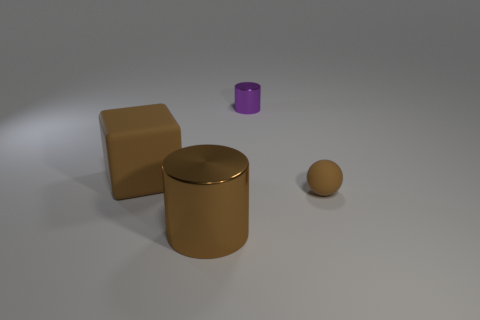Does the small purple metal object have the same shape as the brown shiny thing?
Keep it short and to the point. Yes. There is a small object that is to the right of the small purple shiny thing; are there any cubes that are behind it?
Give a very brief answer. Yes. Is there a brown metal object?
Your answer should be very brief. Yes. There is a object that is to the left of the metallic cylinder in front of the small purple cylinder; what is its color?
Ensure brevity in your answer.  Brown. What number of brown metallic things are the same size as the brown rubber ball?
Make the answer very short. 0. What is the size of the thing that is the same material as the sphere?
Provide a succinct answer. Large. How many large brown things are the same shape as the tiny purple thing?
Offer a very short reply. 1. What number of small brown balls are there?
Your answer should be very brief. 1. Does the shiny thing that is behind the big metal object have the same shape as the brown metallic object?
Your response must be concise. Yes. What is the material of the brown thing that is the same size as the cube?
Offer a terse response. Metal. 